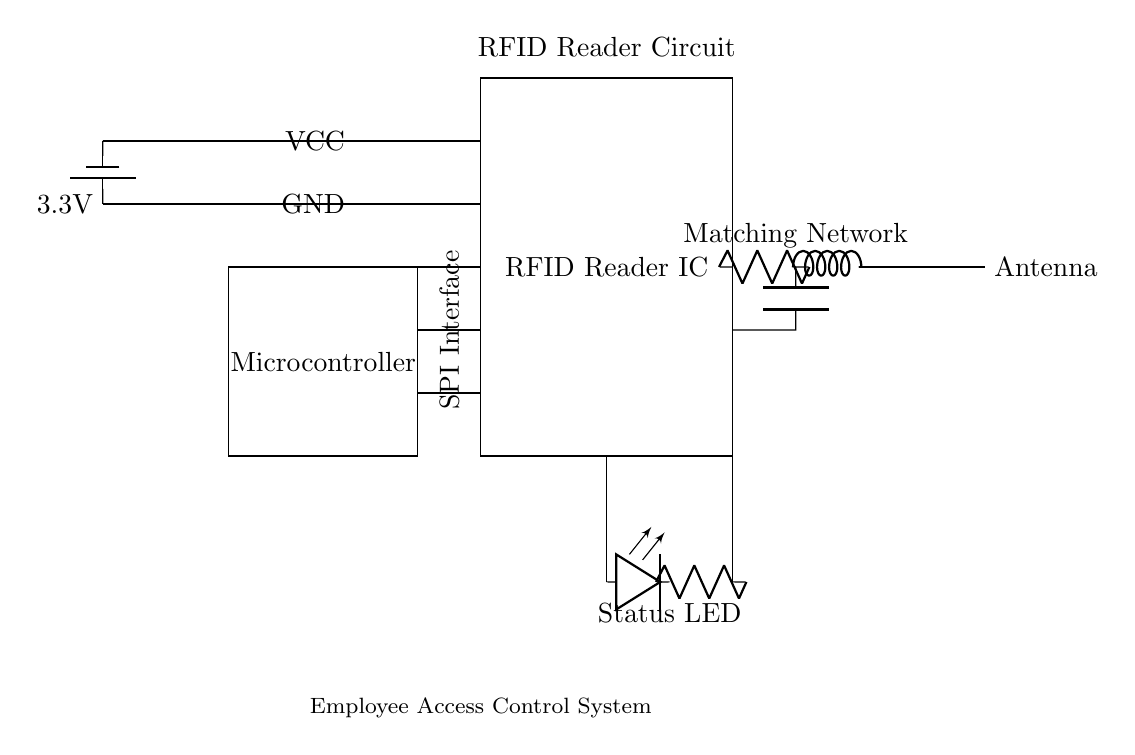What is the main component of this circuit? The main component is the RFID Reader IC, which is crucial for reading RFID tags to control access. It is visually represented as a rectangle labeled 'RFID Reader IC'.
Answer: RFID Reader IC What is the voltage level supplied to this circuit? The circuit is powered by a 3.3V battery, indicated by the battery symbol connected to the voltage supply line.
Answer: 3.3V What does the LED indicate in this circuit? The LED is labeled as 'Status LED', which typically indicates the operational status of the RFID reader, such as power on or successful reading.
Answer: Status How many components are connected to the microcontroller? There are three connections labeled VCC, GND, and a SPI interface connecting to the microcontroller, indicating its essential connections to power and communication.
Answer: Three What is the purpose of the matching network in this circuit? The matching network adjusts the impedance between the RFID reader and the antenna for optimal signal transmission, depicted by the combination of resistors, capacitors, and inductors.
Answer: Impedance matching Which component is responsible for feeding power to the circuit? The battery, shown on the left side connected to the power supply lines, is responsible for feeding power to the entire circuit, providing a stable voltage.
Answer: Battery What does the antenna do in relation to the RFID reader? The antenna is used for transmitting and receiving RFID signals, enabling communication between the reader and RFID tags, as represented in the circuit.
Answer: Communication 